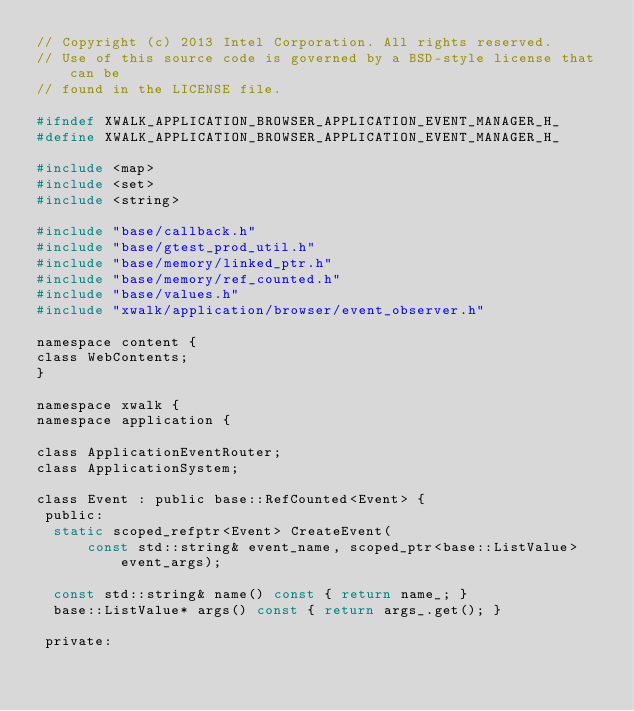<code> <loc_0><loc_0><loc_500><loc_500><_C_>// Copyright (c) 2013 Intel Corporation. All rights reserved.
// Use of this source code is governed by a BSD-style license that can be
// found in the LICENSE file.

#ifndef XWALK_APPLICATION_BROWSER_APPLICATION_EVENT_MANAGER_H_
#define XWALK_APPLICATION_BROWSER_APPLICATION_EVENT_MANAGER_H_

#include <map>
#include <set>
#include <string>

#include "base/callback.h"
#include "base/gtest_prod_util.h"
#include "base/memory/linked_ptr.h"
#include "base/memory/ref_counted.h"
#include "base/values.h"
#include "xwalk/application/browser/event_observer.h"

namespace content {
class WebContents;
}

namespace xwalk {
namespace application {

class ApplicationEventRouter;
class ApplicationSystem;

class Event : public base::RefCounted<Event> {
 public:
  static scoped_refptr<Event> CreateEvent(
      const std::string& event_name, scoped_ptr<base::ListValue> event_args);

  const std::string& name() const { return name_; }
  base::ListValue* args() const { return args_.get(); }

 private:</code> 